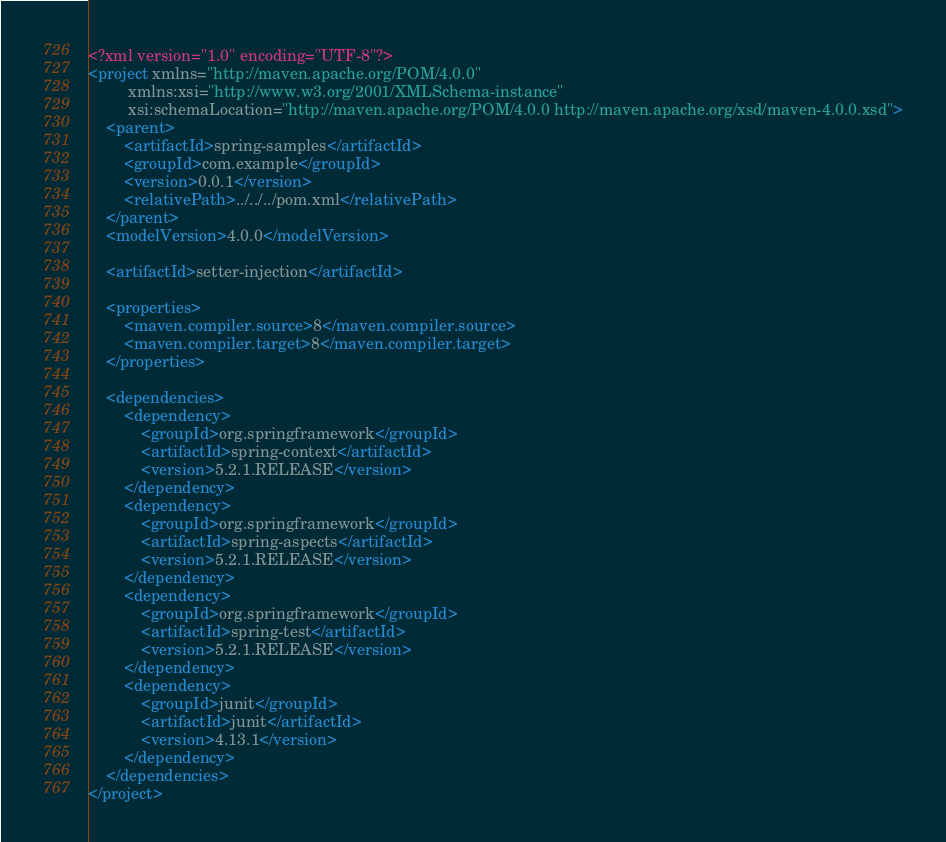<code> <loc_0><loc_0><loc_500><loc_500><_XML_><?xml version="1.0" encoding="UTF-8"?>
<project xmlns="http://maven.apache.org/POM/4.0.0"
         xmlns:xsi="http://www.w3.org/2001/XMLSchema-instance"
         xsi:schemaLocation="http://maven.apache.org/POM/4.0.0 http://maven.apache.org/xsd/maven-4.0.0.xsd">
    <parent>
        <artifactId>spring-samples</artifactId>
        <groupId>com.example</groupId>
        <version>0.0.1</version>
        <relativePath>../../../pom.xml</relativePath>
    </parent>
    <modelVersion>4.0.0</modelVersion>

    <artifactId>setter-injection</artifactId>

    <properties>
        <maven.compiler.source>8</maven.compiler.source>
        <maven.compiler.target>8</maven.compiler.target>
    </properties>

    <dependencies>
        <dependency>
            <groupId>org.springframework</groupId>
            <artifactId>spring-context</artifactId>
            <version>5.2.1.RELEASE</version>
        </dependency>
        <dependency>
            <groupId>org.springframework</groupId>
            <artifactId>spring-aspects</artifactId>
            <version>5.2.1.RELEASE</version>
        </dependency>
        <dependency>
            <groupId>org.springframework</groupId>
            <artifactId>spring-test</artifactId>
            <version>5.2.1.RELEASE</version>
        </dependency>
        <dependency>
            <groupId>junit</groupId>
            <artifactId>junit</artifactId>
            <version>4.13.1</version>
        </dependency>
    </dependencies>
</project></code> 